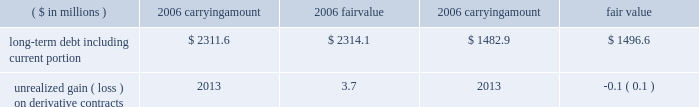Page 78 of 98 notes to consolidated financial statements ball corporation and subsidiaries 17 .
Financial instruments and risk management ( continued ) at december 31 , 2006 , the company had outstanding interest rate swap agreements in europe with notional amounts of 20ac135 million paying fixed rates .
Approximately $ 4 million of net gain associated with these contracts is included in accumulated other comprehensive loss at december 31 , 2006 , of which $ 0.8 million is expected to be recognized in the consolidated statement of earnings during 2007 .
Approximately $ 1.1 million of net gain related to the termination or deselection of hedges is included in accumulated other comprehensive loss at december 31 , 2006 .
The amount recognized in 2006 earnings related to terminated hedges was insignificant .
The fair value of all non-derivative financial instruments approximates their carrying amounts with the exception of long-term debt .
Rates currently available to the company for loans with similar terms and maturities are used to estimate the fair value of long-term debt based on discounted cash flows .
The fair value of derivatives generally reflects the estimated amounts that we would pay or receive upon termination of the contracts at december 31 , 2006 , taking into account any unrealized gains and losses on open contracts. .
Foreign currency exchange rate risk our objective in managing exposure to foreign currency fluctuations is to protect foreign cash flows and earnings from changes associated with foreign currency exchange rate changes through the use of cash flow hedges .
In addition , we manage foreign earnings translation volatility through the use of foreign currency options .
Our foreign currency translation risk results from the european euro , british pound , canadian dollar , polish zloty , serbian dinar , brazilian real , argentine peso and chinese renminbi .
We face currency exposures in our global operations as a result of purchasing raw materials in u.s .
Dollars and , to a lesser extent , in other currencies .
Sales contracts are negotiated with customers to reflect cost changes and , where there is not a foreign exchange pass-through arrangement , the company uses forward and option contracts to manage foreign currency exposures .
Such contracts outstanding at december 31 , 2006 , expire within four years and there are no amounts included in accumulated other comprehensive loss related to these contracts. .
Approximately what percent of the net gain on hedging in aoci at 12/31/06 is expected to impact net income during 2007? 
Computations: (0.8 / 4)
Answer: 0.2. 